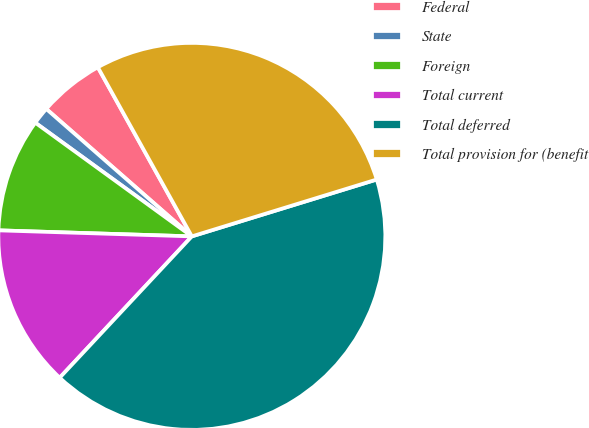Convert chart to OTSL. <chart><loc_0><loc_0><loc_500><loc_500><pie_chart><fcel>Federal<fcel>State<fcel>Foreign<fcel>Total current<fcel>Total deferred<fcel>Total provision for (benefit<nl><fcel>5.48%<fcel>1.45%<fcel>9.5%<fcel>13.53%<fcel>41.71%<fcel>28.32%<nl></chart> 